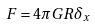Convert formula to latex. <formula><loc_0><loc_0><loc_500><loc_500>F = 4 \pi G R \delta _ { x }</formula> 